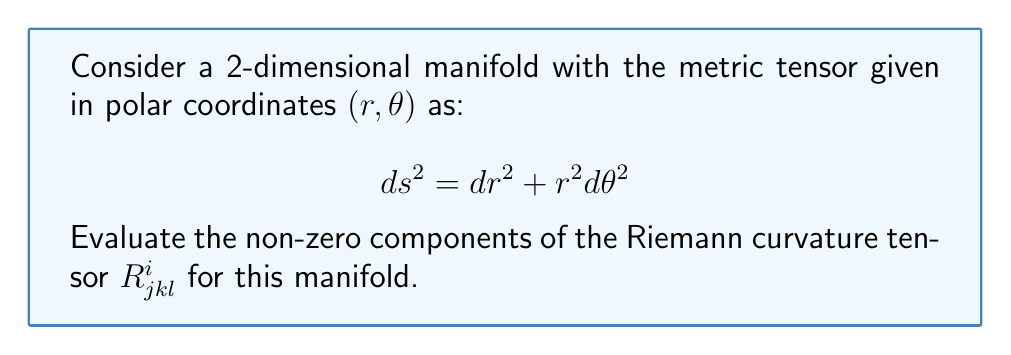Provide a solution to this math problem. Let's approach this step-by-step:

1) First, we need to calculate the Christoffel symbols. The non-zero Christoffel symbols for this metric are:

   $$\Gamma^r_{\theta\theta} = -r$$
   $$\Gamma^\theta_{r\theta} = \Gamma^\theta_{\theta r} = \frac{1}{r}$$

2) The Riemann curvature tensor is given by:

   $$R^i_{jkl} = \partial_k \Gamma^i_{jl} - \partial_l \Gamma^i_{jk} + \Gamma^i_{mk}\Gamma^m_{jl} - \Gamma^i_{ml}\Gamma^m_{jk}$$

3) Let's calculate the non-zero components:

   For $R^r_{\theta r \theta}$:
   $$\begin{aligned}
   R^r_{\theta r \theta} &= \partial_r \Gamma^r_{\theta\theta} - \partial_\theta \Gamma^r_{\theta r} + \Gamma^r_{mr}\Gamma^m_{\theta\theta} - \Gamma^r_{m\theta}\Gamma^m_{\theta r} \\
   &= -1 - 0 + 0 - 0 = -1
   \end{aligned}$$

   For $R^\theta_{r \theta r}$:
   $$\begin{aligned}
   R^\theta_{r \theta r} &= \partial_\theta \Gamma^\theta_{rr} - \partial_r \Gamma^\theta_{r\theta} + \Gamma^\theta_{m\theta}\Gamma^m_{rr} - \Gamma^\theta_{mr}\Gamma^m_{r\theta} \\
   &= 0 - (-\frac{1}{r^2}) + 0 - \frac{1}{r} \cdot \frac{1}{r} = \frac{1}{r^2} - \frac{1}{r^2} = 0
   \end{aligned}$$

4) The other components can be derived from these using the symmetries of the Riemann tensor:

   $$R^r_{\theta r \theta} = -R^r_{\theta \theta r} = R^r_{r \theta \theta} = -1$$
   $$R^\theta_{r \theta r} = -R^\theta_{r r \theta} = R^\theta_{\theta r r} = 0$$

5) All other components are zero due to the symmetries of the Riemann tensor.
Answer: $R^r_{\theta r \theta} = -R^r_{\theta \theta r} = R^r_{r \theta \theta} = -1$; all other components are zero. 